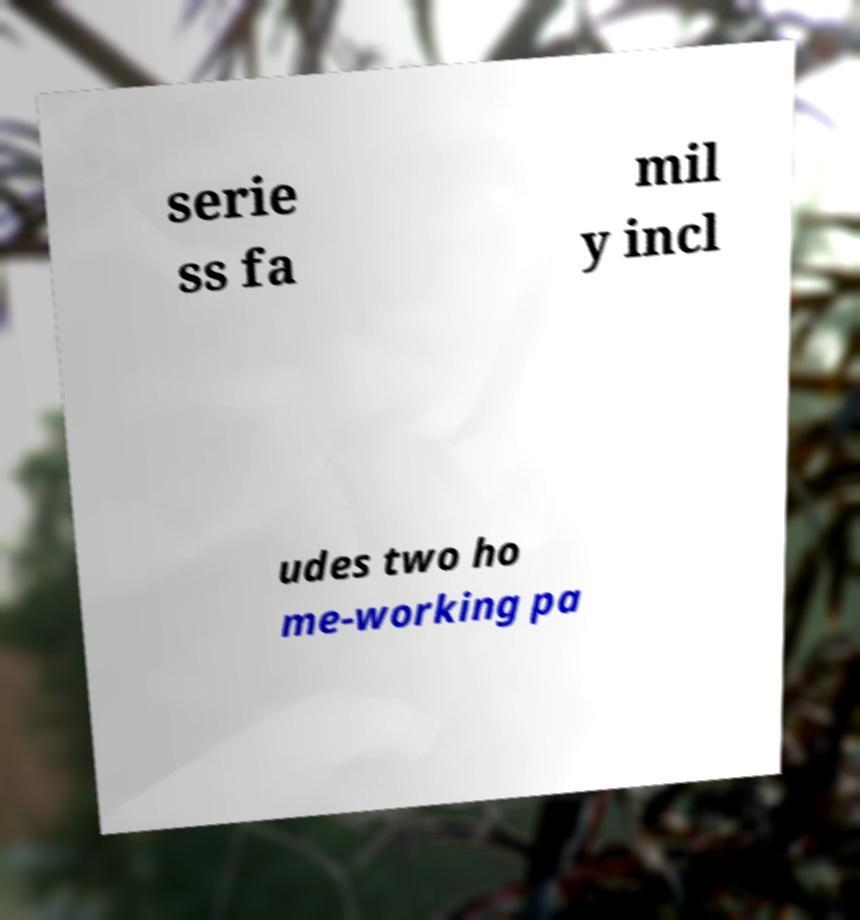For documentation purposes, I need the text within this image transcribed. Could you provide that? serie ss fa mil y incl udes two ho me-working pa 